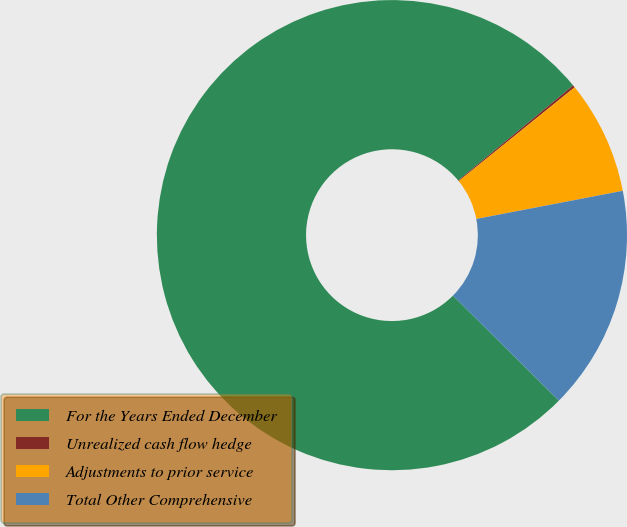Convert chart. <chart><loc_0><loc_0><loc_500><loc_500><pie_chart><fcel>For the Years Ended December<fcel>Unrealized cash flow hedge<fcel>Adjustments to prior service<fcel>Total Other Comprehensive<nl><fcel>76.58%<fcel>0.16%<fcel>7.81%<fcel>15.45%<nl></chart> 